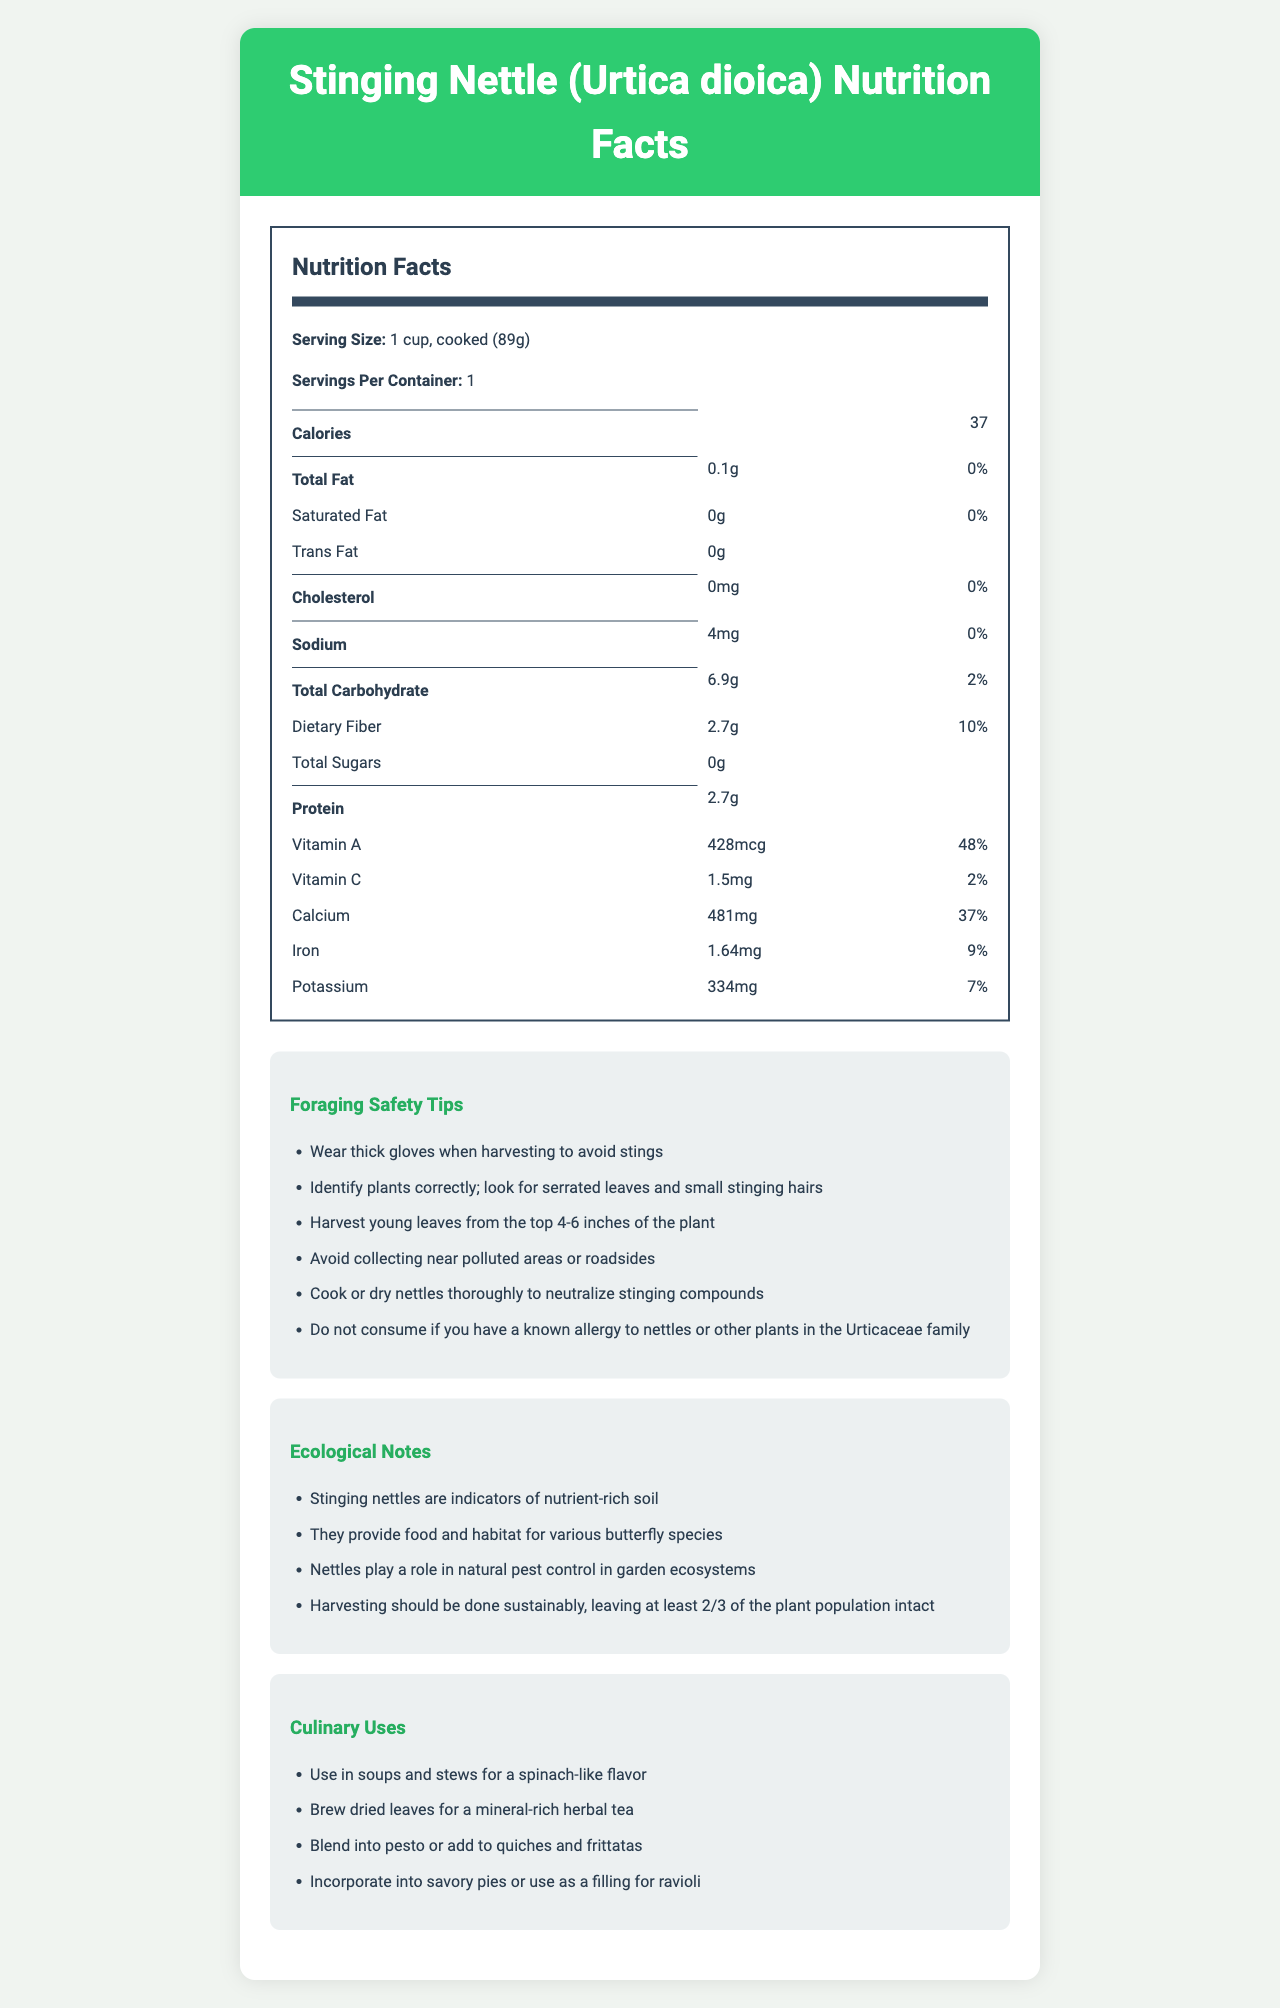What is the serving size for Stinging Nettle? The serving size is stated in the "Nutrition Facts" section.
Answer: 1 cup, cooked (89g) How many calories are in one serving of Stinging Nettle? The calories per serving are listed as 37 in the "Nutrition Facts" section.
Answer: 37 What is the daily value percentage of calcium in one serving? The percent daily value for calcium is given as 37% in the "Nutrition Facts" section.
Answer: 37% Is there any trans fat in Stinging Nettle? The "Nutrition Facts" section indicates "Trans Fat 0g," implying there is no trans fat.
Answer: No What is the protein content in one serving of Stinging Nettle? The protein content is listed as 2.7g in the "Nutrition Facts" section.
Answer: 2.7g Which safety tip is recommended to avoid stings while harvesting nettles? A. Harvest at dawn B. Use thick gloves C. Avoid young leaves The document states "Wear thick gloves when harvesting to avoid stings."
Answer: B What is the recommended way to neutralize the stinging compounds in nettles? A. Soak in vinegar B. Freeze overnight C. Cook or dry The safety tip indicates "Cook or dry nettles thoroughly to neutralize stinging compounds."
Answer: C Which vitamin does Stinging Nettle provide the most of in terms of daily value percentage? A. Vitamin A B. Vitamin C C. Vitamin D The daily value percentage for Vitamin A is 48% while for Vitamin C it is 2%, and Vitamin D is not mentioned, making Vitamin A the highest.
Answer: A True or False: Stinging Nettle is a significant source of dietary fiber. Stinging Nettle provides 2.7g of dietary fiber, which is 10% of the daily value.
Answer: True Summarize the main nutritional benefits and safety tips for Stinging Nettle. The document provides detailed nutritional information, highlighting Stinging Nettle's high content of Vitamin A and calcium and its low-calorie profile. It also outlines important safety tips like wearing gloves and cooking the plant to avoid stings and ensuring correct plant identification.
Answer: Stinging Nettle is a highly nutritious plant that offers vitamins, minerals, and protein while being low in calories and fat. It is particularly rich in Vitamin A and calcium. For safe foraging, wear thick gloves, correctly identify the plant, harvest young leaves, and cook or dry it thoroughly to neutralize stinging compounds. Avoid polluted areas and be cautious of allergies. What are some ecological roles of Stinging Nettle mentioned in the document? The ecological roles listed in the "Ecological Notes" section include nutrient-rich soil indicators, providing food and habitat for butterflies, aiding in pest control, and recommending sustainable harvesting practices.
Answer: Indicators of nutrient-rich soil, food and habitat for butterfly species, natural pest control, sustainable harvesting. What is one culinary use of Stinging Nettle? One culinary use mentioned is to "Use in soups and stews for a spinach-like flavor."
Answer: Use in soups and stews What is the total carbohydrate content per serving? The total carbohydrate content is listed as 6.9g in the "Nutrition Facts" section.
Answer: 6.9g How much sodium does one serving of Stinging Nettle contain? The sodium content per serving is listed as 4mg in the "Nutrition Facts" section.
Answer: 4mg Which plant family does Stinging Nettle belong to? The plant family is mentioned in the foraging safety tip, advising caution if allergic to plants in the Urticaceae family.
Answer: Urticaceae Why should you avoid collecting Stinging Nettle near polluted areas or roadsides? The safety tip advises avoiding polluted areas due to potential contamination with harmful substances.
Answer: Potential contamination What should you do if you have a known allergy to nettles or other plants in the Urticaceae family? The document advises not to consume Stinging Nettle if there's a known allergy to nettles or other Urticaceae plants.
Answer: Avoid consuming Where should you harvest young leaves of nettles from the plant? The safety tips recommend harvesting young leaves from the top 4-6 inches of the plant.
Answer: The top 4-6 inches of the plant What is the primary design style of the document? The document uses a clean and nature-themed design with a light background color and green accents related to nature and health.
Answer: Clean and nature-themed with light background and green accents What is the carbohydrate percentage of daily value in one serving? The total carbohydrate percentage of daily value is listed as 2% in the "Nutrition Facts" section.
Answer: 2% Where do nettles provide significant ecological benefits? Ecological notes mention nettles' role in garden ecosystems for pest control and as habitats for butterflies.
Answer: Garden ecosystems (pest control), butterfly habitats Identify an unlisted vitamin content in Stinging Nettle. The document does not provide information about vitamins other than Vitamin A and Vitamin C.
Answer: Not enough information 